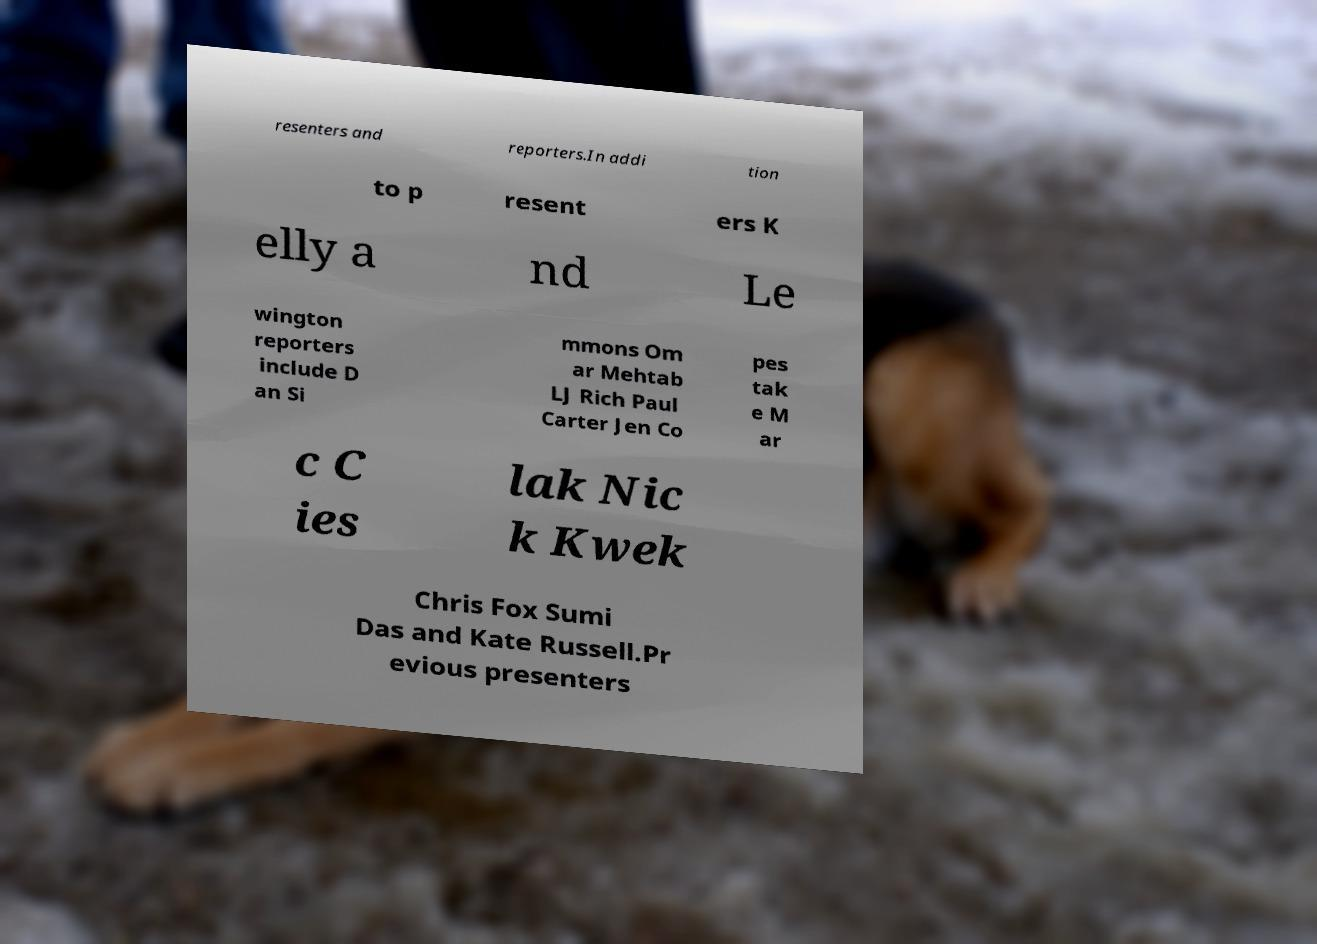Could you extract and type out the text from this image? resenters and reporters.In addi tion to p resent ers K elly a nd Le wington reporters include D an Si mmons Om ar Mehtab LJ Rich Paul Carter Jen Co pes tak e M ar c C ies lak Nic k Kwek Chris Fox Sumi Das and Kate Russell.Pr evious presenters 